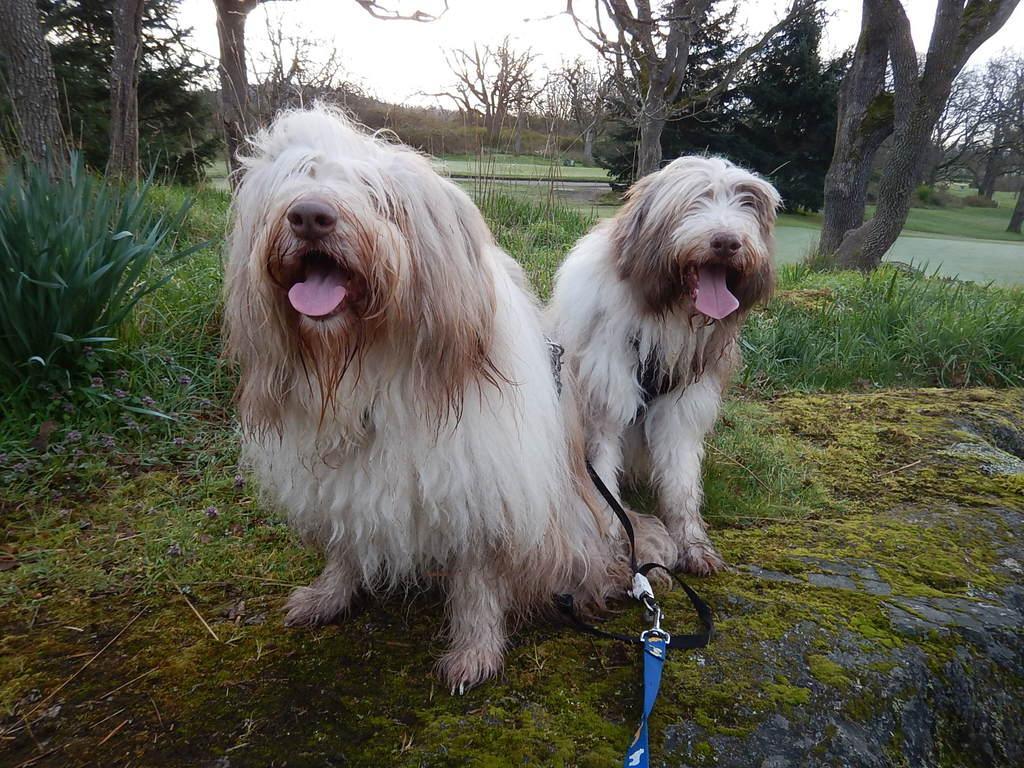Can you describe this image briefly? In this image we can see two dogs which is in white and brown color which has leash and in the background of image there are some trees and clear sky. 